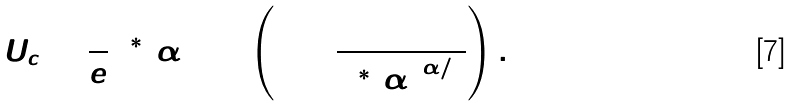<formula> <loc_0><loc_0><loc_500><loc_500>U _ { c } = \frac { 1 } { e } \Lambda ^ { * } ( \alpha ) \log \left ( 1 + \frac { 1 } { { \Lambda ^ { * } ( \alpha ) } ^ { \alpha / 2 } } \right ) .</formula> 